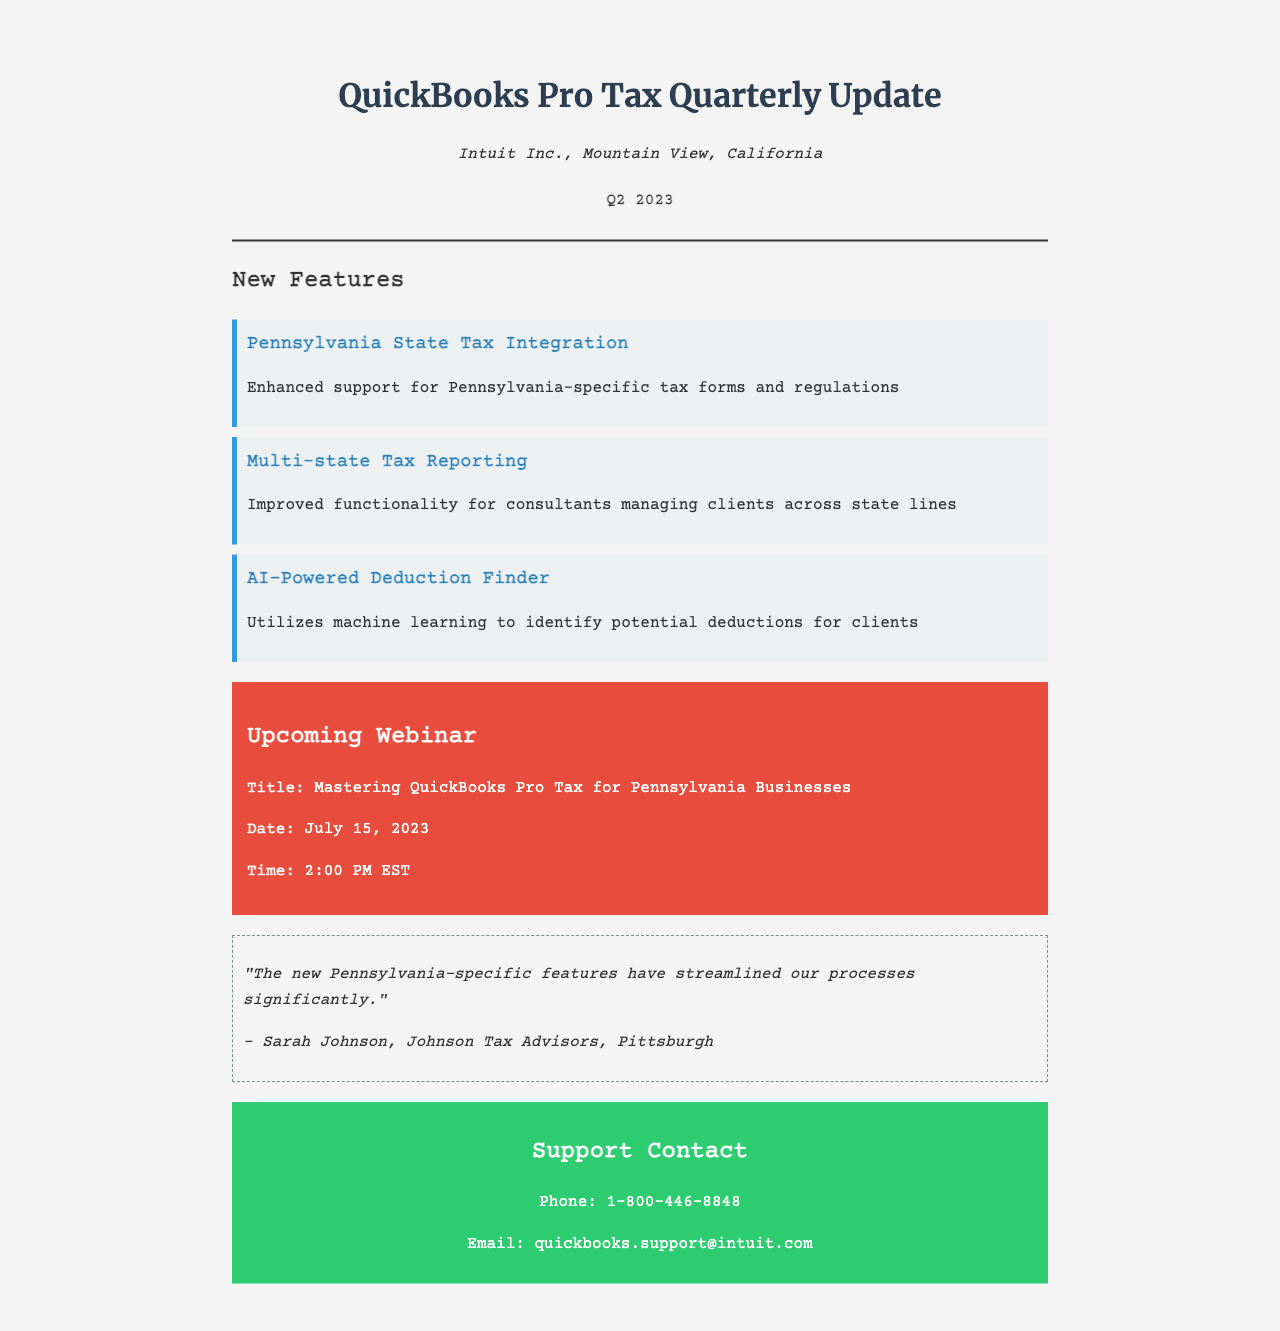What is the name of the company? The company name is mentioned in the fax as Intuit Inc.
Answer: Intuit Inc What is the quarter and year of this report? The report specifies it is for Q2 2023.
Answer: Q2 2023 What is one of the new features related to Pennsylvania? The document highlights "Pennsylvania State Tax Integration" as a new feature.
Answer: Pennsylvania State Tax Integration When is the upcoming webinar scheduled? The specific date mentioned in the document for the webinar is July 15, 2023.
Answer: July 15, 2023 What time will the webinar start? The webinar time is indicated as 2:00 PM EST.
Answer: 2:00 PM EST Who provided a testimonial about the new features? The testimonial is from Sarah Johnson, mentioned in the document.
Answer: Sarah Johnson What is the phone number for support? The support contact phone number is indicated in the document as 1-800-446-8848.
Answer: 1-800-446-8848 What technology does the AI-powered feature utilize? The feature is described as utilizing machine learning.
Answer: Machine learning What city is Johnson Tax Advisors located in? The document mentions Pittsburgh as the location of Johnson Tax Advisors.
Answer: Pittsburgh 